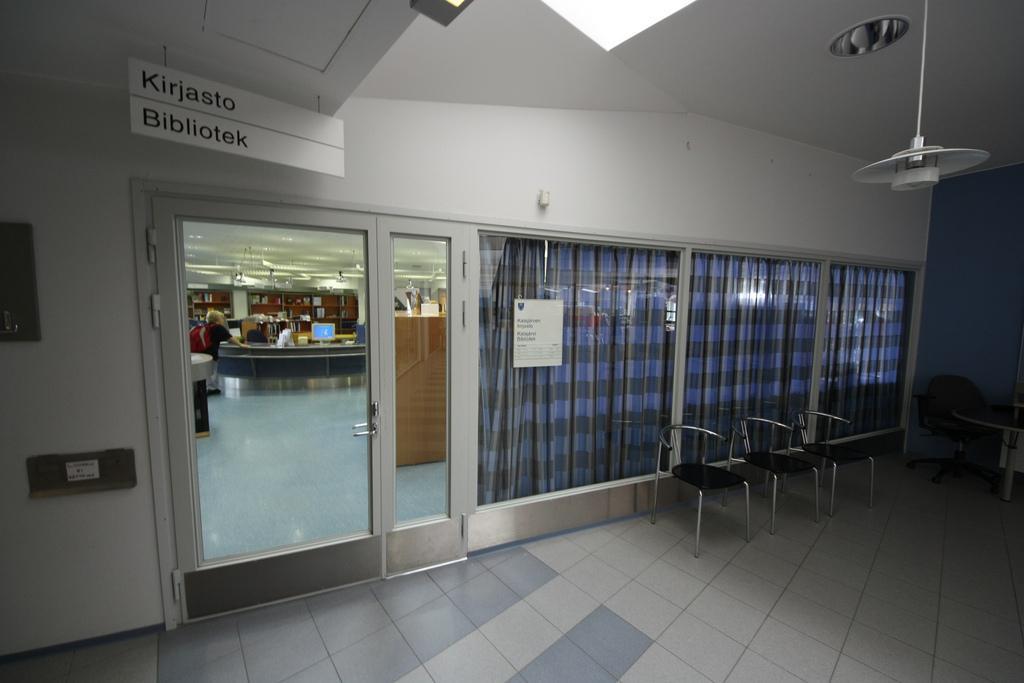Could you give a brief overview of what you see in this image? In this picture I see the inside view of a room and I see the chairs and on the ceiling I see the light and on the left of this image I see a board on which there is something written and I see the door glass through which I see another room and I see few people and I see few more lights on the ceiling and on the right side of this image I see the curtains. 